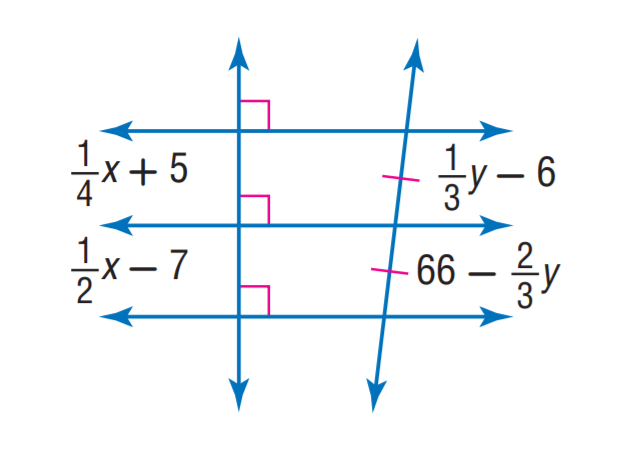Answer the mathemtical geometry problem and directly provide the correct option letter.
Question: Find x.
Choices: A: 36 B: 48 C: 66 D: 72 B 